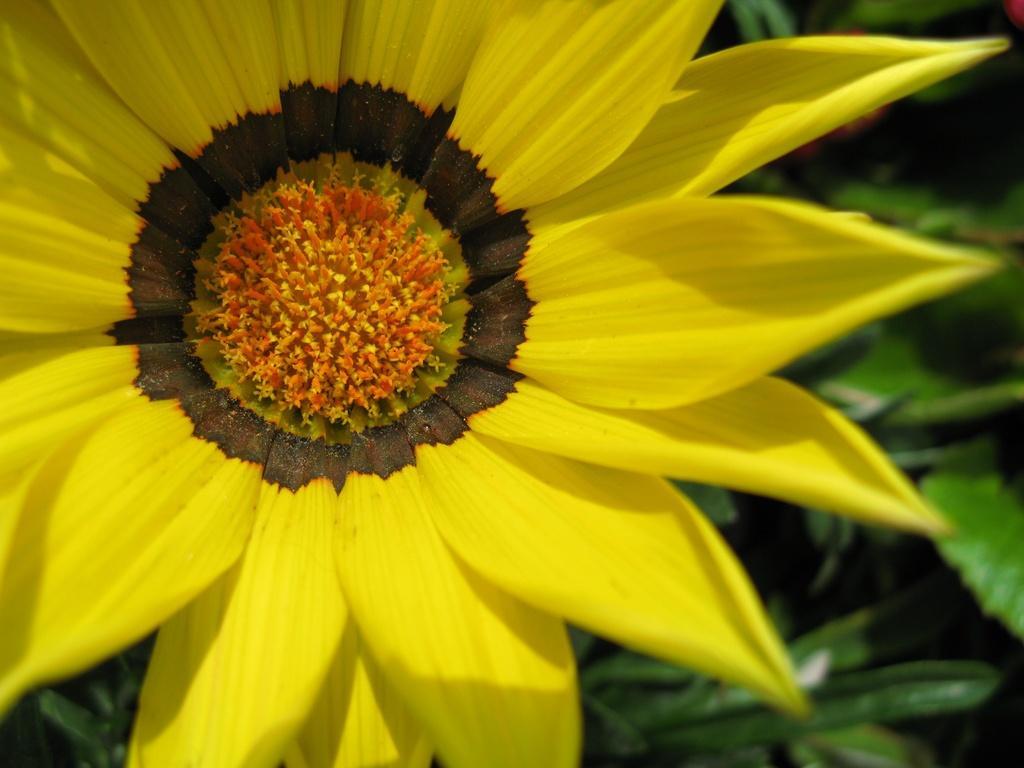Can you describe this image briefly? In this picture we can see a flower and behind the flower there are leaves. 